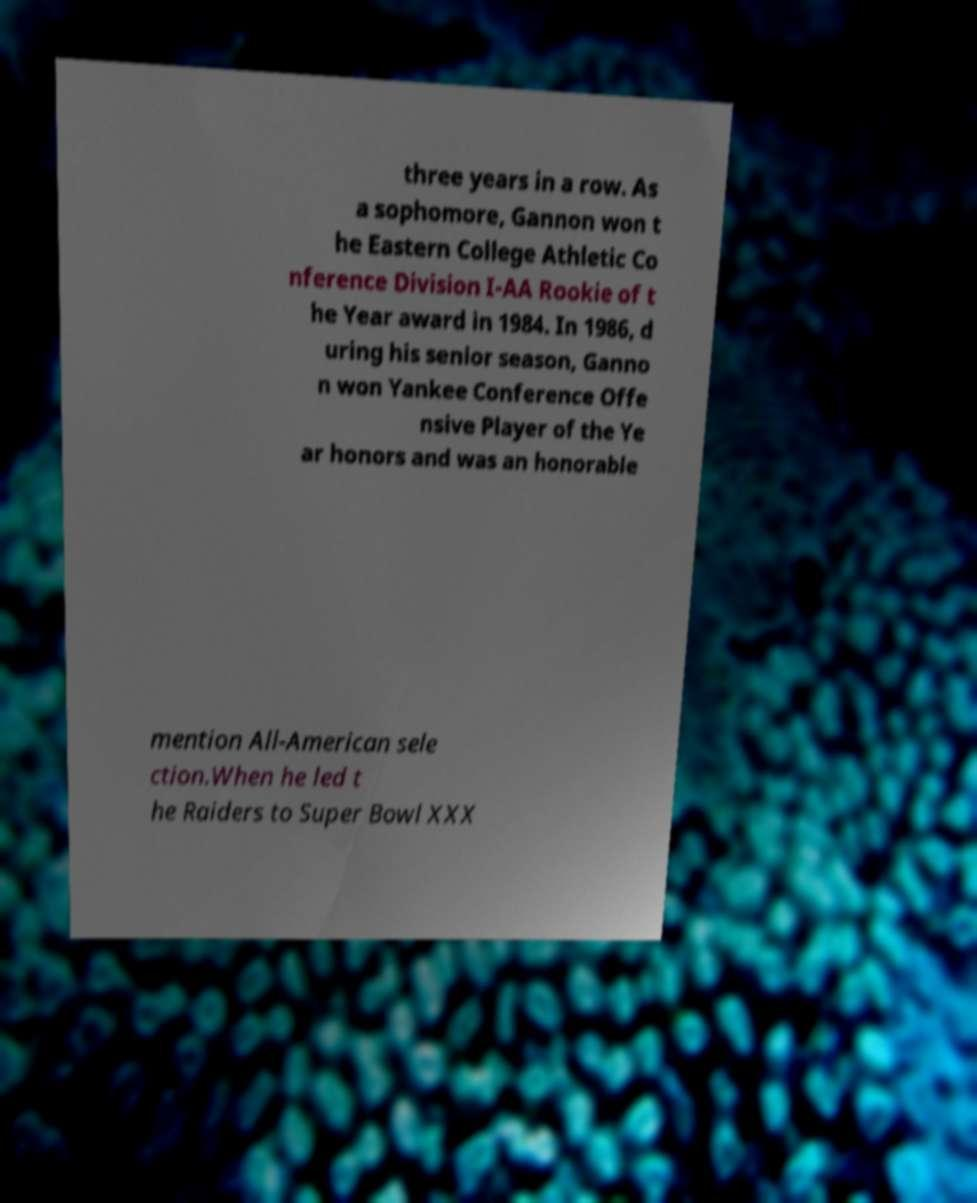Can you read and provide the text displayed in the image?This photo seems to have some interesting text. Can you extract and type it out for me? three years in a row. As a sophomore, Gannon won t he Eastern College Athletic Co nference Division I-AA Rookie of t he Year award in 1984. In 1986, d uring his senior season, Ganno n won Yankee Conference Offe nsive Player of the Ye ar honors and was an honorable mention All-American sele ction.When he led t he Raiders to Super Bowl XXX 